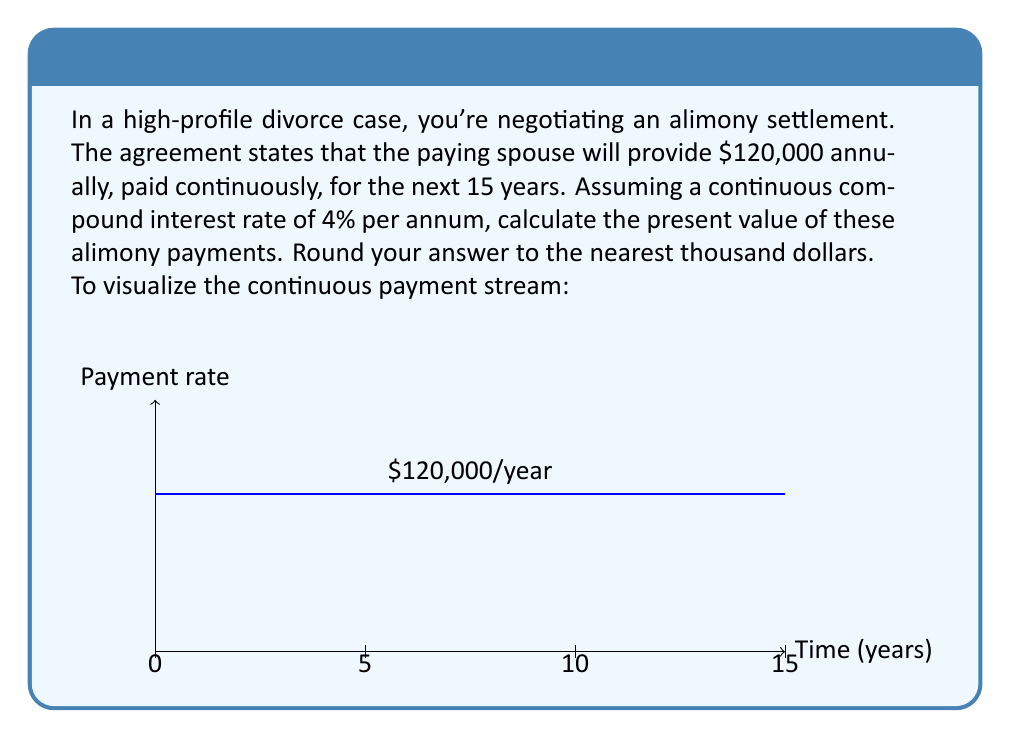Solve this math problem. To solve this problem, we'll use the continuous-time present value formula:

$$ PV = \int_0^T A e^{-rt} dt $$

Where:
- $PV$ is the present value
- $A$ is the annual payment rate
- $r$ is the continuous compound interest rate
- $T$ is the time period in years

Given:
- $A = 120,000$
- $r = 0.04$ (4% expressed as a decimal)
- $T = 15$ years

Step 1: Set up the integral
$$ PV = \int_0^{15} 120,000 e^{-0.04t} dt $$

Step 2: Solve the integral
$$ PV = -120,000 \cdot \frac{1}{-0.04} \cdot [e^{-0.04t}]_0^{15} $$
$$ PV = 3,000,000 \cdot [e^{-0.04 \cdot 15} - e^{-0.04 \cdot 0}] $$
$$ PV = 3,000,000 \cdot [e^{-0.6} - 1] $$

Step 3: Calculate the result
$$ PV = 3,000,000 \cdot [0.5488116 - 1] $$
$$ PV = 3,000,000 \cdot (-0.4511884) $$
$$ PV = -1,353,565.20 $$

Step 4: Take the absolute value and round to the nearest thousand
$$ PV \approx 1,354,000 $$
Answer: $1,354,000 